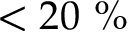Convert formula to latex. <formula><loc_0><loc_0><loc_500><loc_500>< 2 0 \%</formula> 